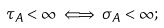Convert formula to latex. <formula><loc_0><loc_0><loc_500><loc_500>\tau _ { A } < \infty \iff \sigma _ { A } < \infty ;</formula> 